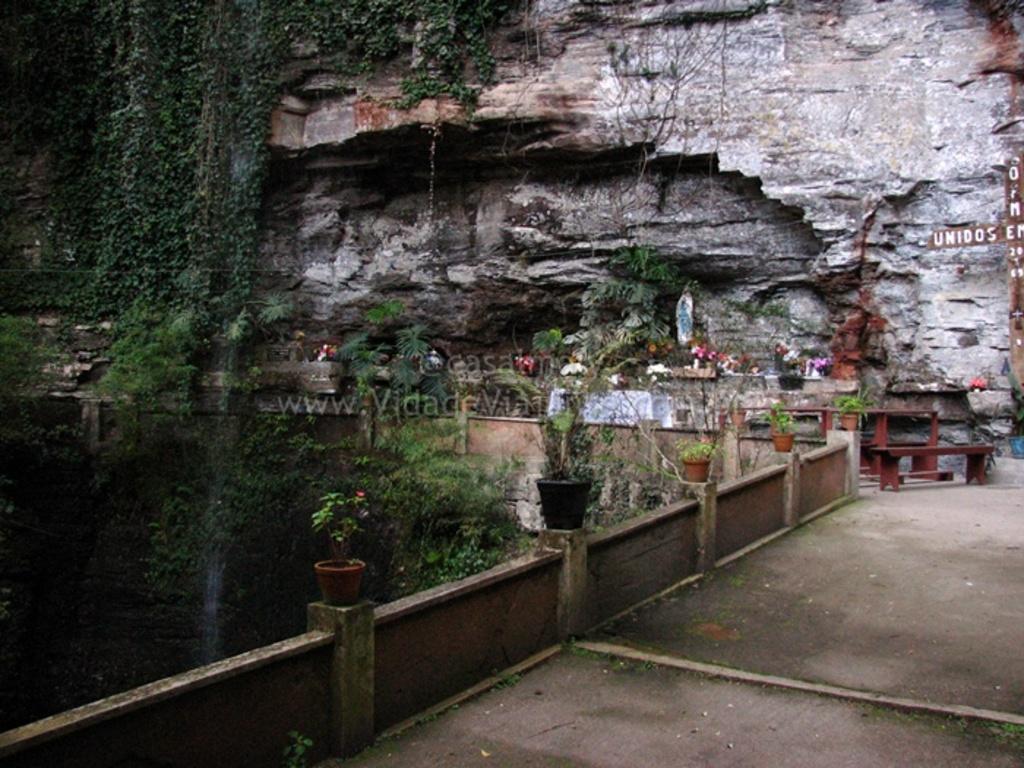How would you summarize this image in a sentence or two? In the picture I can see flower pots are placed on the wall, I can see tables, trees, Creepers and the stone wall in the background. 